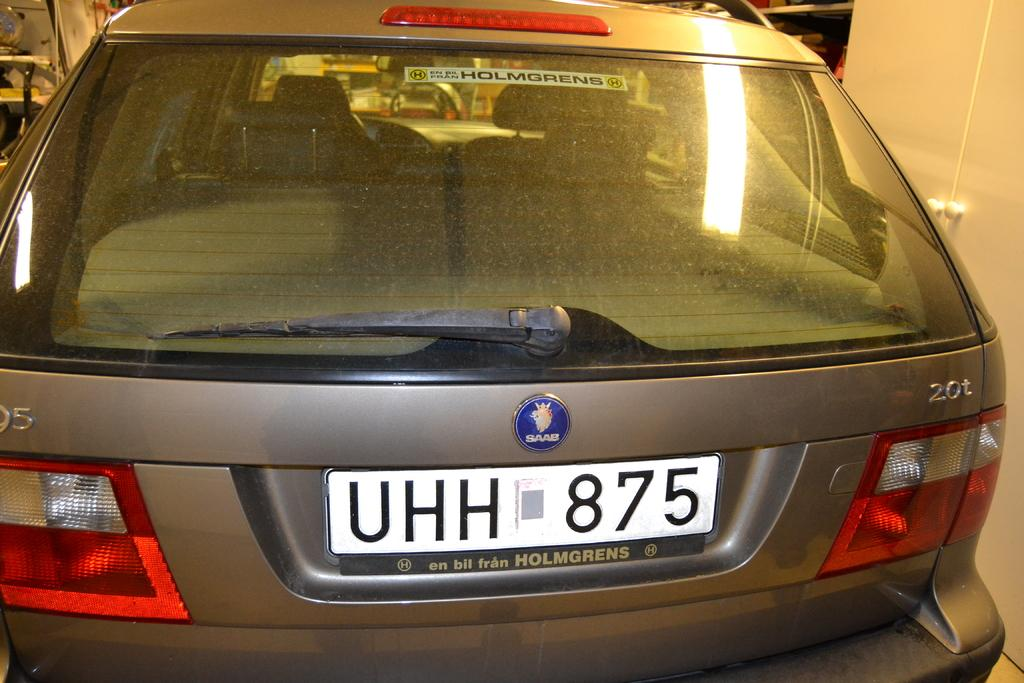<image>
Present a compact description of the photo's key features. UHH 875 reads the license plate on the rear of this SAAB. 